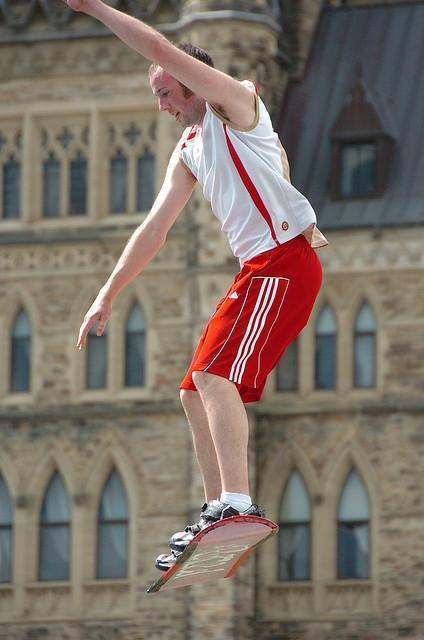How many vases have flowers in them?
Give a very brief answer. 0. 